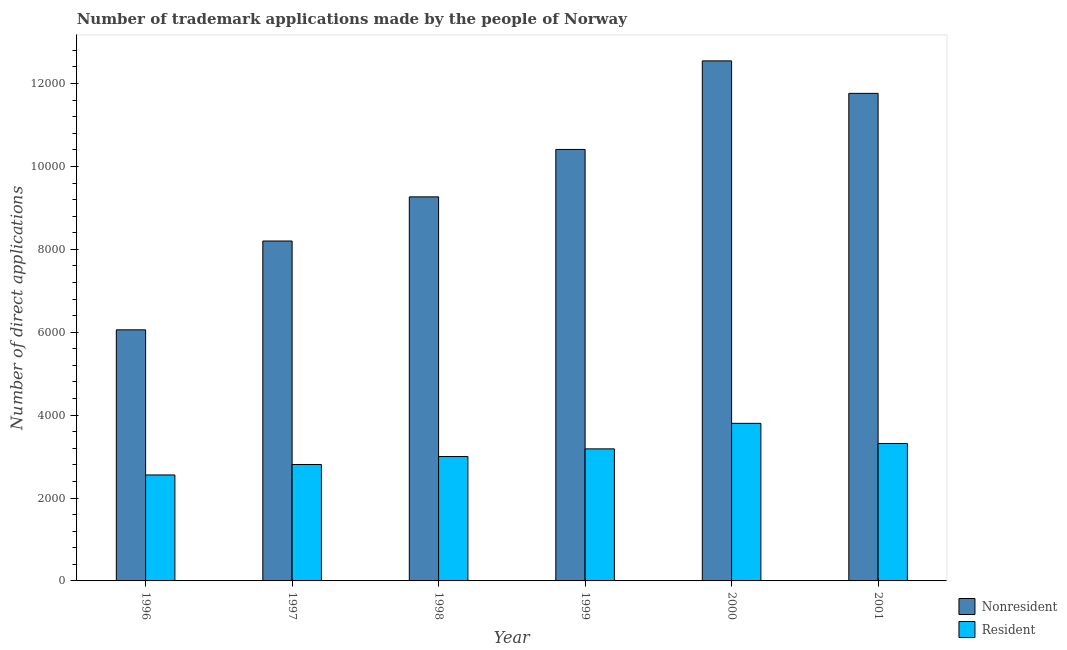How many different coloured bars are there?
Your answer should be very brief. 2. How many groups of bars are there?
Your answer should be very brief. 6. How many bars are there on the 1st tick from the left?
Provide a short and direct response. 2. What is the number of trademark applications made by residents in 1997?
Make the answer very short. 2809. Across all years, what is the maximum number of trademark applications made by non residents?
Your answer should be compact. 1.25e+04. Across all years, what is the minimum number of trademark applications made by residents?
Your response must be concise. 2557. What is the total number of trademark applications made by non residents in the graph?
Your answer should be compact. 5.82e+04. What is the difference between the number of trademark applications made by residents in 1997 and that in 1999?
Your response must be concise. -377. What is the difference between the number of trademark applications made by non residents in 1997 and the number of trademark applications made by residents in 1996?
Your response must be concise. 2143. What is the average number of trademark applications made by residents per year?
Offer a very short reply. 3111.83. In how many years, is the number of trademark applications made by residents greater than 6000?
Make the answer very short. 0. What is the ratio of the number of trademark applications made by non residents in 1997 to that in 2000?
Make the answer very short. 0.65. Is the number of trademark applications made by non residents in 1996 less than that in 1999?
Make the answer very short. Yes. Is the difference between the number of trademark applications made by residents in 1998 and 2000 greater than the difference between the number of trademark applications made by non residents in 1998 and 2000?
Offer a very short reply. No. What is the difference between the highest and the second highest number of trademark applications made by non residents?
Keep it short and to the point. 784. What is the difference between the highest and the lowest number of trademark applications made by residents?
Make the answer very short. 1245. What does the 2nd bar from the left in 1999 represents?
Offer a terse response. Resident. What does the 1st bar from the right in 1999 represents?
Offer a terse response. Resident. How many bars are there?
Your answer should be compact. 12. Are all the bars in the graph horizontal?
Keep it short and to the point. No. How many years are there in the graph?
Provide a succinct answer. 6. Does the graph contain any zero values?
Make the answer very short. No. Where does the legend appear in the graph?
Provide a short and direct response. Bottom right. What is the title of the graph?
Keep it short and to the point. Number of trademark applications made by the people of Norway. Does "Electricity" appear as one of the legend labels in the graph?
Provide a succinct answer. No. What is the label or title of the Y-axis?
Your answer should be compact. Number of direct applications. What is the Number of direct applications of Nonresident in 1996?
Ensure brevity in your answer.  6058. What is the Number of direct applications of Resident in 1996?
Keep it short and to the point. 2557. What is the Number of direct applications in Nonresident in 1997?
Ensure brevity in your answer.  8201. What is the Number of direct applications in Resident in 1997?
Give a very brief answer. 2809. What is the Number of direct applications in Nonresident in 1998?
Offer a terse response. 9266. What is the Number of direct applications in Resident in 1998?
Offer a very short reply. 3001. What is the Number of direct applications in Nonresident in 1999?
Provide a succinct answer. 1.04e+04. What is the Number of direct applications of Resident in 1999?
Provide a succinct answer. 3186. What is the Number of direct applications of Nonresident in 2000?
Give a very brief answer. 1.25e+04. What is the Number of direct applications in Resident in 2000?
Your answer should be compact. 3802. What is the Number of direct applications of Nonresident in 2001?
Your answer should be compact. 1.18e+04. What is the Number of direct applications in Resident in 2001?
Provide a short and direct response. 3316. Across all years, what is the maximum Number of direct applications in Nonresident?
Give a very brief answer. 1.25e+04. Across all years, what is the maximum Number of direct applications of Resident?
Your answer should be very brief. 3802. Across all years, what is the minimum Number of direct applications of Nonresident?
Offer a terse response. 6058. Across all years, what is the minimum Number of direct applications of Resident?
Your response must be concise. 2557. What is the total Number of direct applications of Nonresident in the graph?
Your answer should be compact. 5.82e+04. What is the total Number of direct applications in Resident in the graph?
Your response must be concise. 1.87e+04. What is the difference between the Number of direct applications of Nonresident in 1996 and that in 1997?
Give a very brief answer. -2143. What is the difference between the Number of direct applications in Resident in 1996 and that in 1997?
Make the answer very short. -252. What is the difference between the Number of direct applications in Nonresident in 1996 and that in 1998?
Keep it short and to the point. -3208. What is the difference between the Number of direct applications of Resident in 1996 and that in 1998?
Your response must be concise. -444. What is the difference between the Number of direct applications in Nonresident in 1996 and that in 1999?
Provide a succinct answer. -4352. What is the difference between the Number of direct applications in Resident in 1996 and that in 1999?
Provide a succinct answer. -629. What is the difference between the Number of direct applications in Nonresident in 1996 and that in 2000?
Make the answer very short. -6489. What is the difference between the Number of direct applications of Resident in 1996 and that in 2000?
Make the answer very short. -1245. What is the difference between the Number of direct applications in Nonresident in 1996 and that in 2001?
Offer a terse response. -5705. What is the difference between the Number of direct applications of Resident in 1996 and that in 2001?
Your answer should be compact. -759. What is the difference between the Number of direct applications of Nonresident in 1997 and that in 1998?
Make the answer very short. -1065. What is the difference between the Number of direct applications of Resident in 1997 and that in 1998?
Give a very brief answer. -192. What is the difference between the Number of direct applications of Nonresident in 1997 and that in 1999?
Make the answer very short. -2209. What is the difference between the Number of direct applications of Resident in 1997 and that in 1999?
Make the answer very short. -377. What is the difference between the Number of direct applications of Nonresident in 1997 and that in 2000?
Offer a terse response. -4346. What is the difference between the Number of direct applications of Resident in 1997 and that in 2000?
Offer a very short reply. -993. What is the difference between the Number of direct applications in Nonresident in 1997 and that in 2001?
Keep it short and to the point. -3562. What is the difference between the Number of direct applications of Resident in 1997 and that in 2001?
Your response must be concise. -507. What is the difference between the Number of direct applications of Nonresident in 1998 and that in 1999?
Ensure brevity in your answer.  -1144. What is the difference between the Number of direct applications in Resident in 1998 and that in 1999?
Your answer should be very brief. -185. What is the difference between the Number of direct applications in Nonresident in 1998 and that in 2000?
Your answer should be very brief. -3281. What is the difference between the Number of direct applications in Resident in 1998 and that in 2000?
Keep it short and to the point. -801. What is the difference between the Number of direct applications of Nonresident in 1998 and that in 2001?
Offer a very short reply. -2497. What is the difference between the Number of direct applications of Resident in 1998 and that in 2001?
Your response must be concise. -315. What is the difference between the Number of direct applications of Nonresident in 1999 and that in 2000?
Provide a short and direct response. -2137. What is the difference between the Number of direct applications of Resident in 1999 and that in 2000?
Keep it short and to the point. -616. What is the difference between the Number of direct applications of Nonresident in 1999 and that in 2001?
Offer a very short reply. -1353. What is the difference between the Number of direct applications of Resident in 1999 and that in 2001?
Your answer should be very brief. -130. What is the difference between the Number of direct applications of Nonresident in 2000 and that in 2001?
Your answer should be compact. 784. What is the difference between the Number of direct applications in Resident in 2000 and that in 2001?
Your answer should be compact. 486. What is the difference between the Number of direct applications of Nonresident in 1996 and the Number of direct applications of Resident in 1997?
Your response must be concise. 3249. What is the difference between the Number of direct applications of Nonresident in 1996 and the Number of direct applications of Resident in 1998?
Keep it short and to the point. 3057. What is the difference between the Number of direct applications of Nonresident in 1996 and the Number of direct applications of Resident in 1999?
Offer a terse response. 2872. What is the difference between the Number of direct applications of Nonresident in 1996 and the Number of direct applications of Resident in 2000?
Your answer should be compact. 2256. What is the difference between the Number of direct applications in Nonresident in 1996 and the Number of direct applications in Resident in 2001?
Provide a succinct answer. 2742. What is the difference between the Number of direct applications in Nonresident in 1997 and the Number of direct applications in Resident in 1998?
Give a very brief answer. 5200. What is the difference between the Number of direct applications of Nonresident in 1997 and the Number of direct applications of Resident in 1999?
Ensure brevity in your answer.  5015. What is the difference between the Number of direct applications in Nonresident in 1997 and the Number of direct applications in Resident in 2000?
Ensure brevity in your answer.  4399. What is the difference between the Number of direct applications in Nonresident in 1997 and the Number of direct applications in Resident in 2001?
Ensure brevity in your answer.  4885. What is the difference between the Number of direct applications of Nonresident in 1998 and the Number of direct applications of Resident in 1999?
Ensure brevity in your answer.  6080. What is the difference between the Number of direct applications of Nonresident in 1998 and the Number of direct applications of Resident in 2000?
Make the answer very short. 5464. What is the difference between the Number of direct applications in Nonresident in 1998 and the Number of direct applications in Resident in 2001?
Offer a terse response. 5950. What is the difference between the Number of direct applications in Nonresident in 1999 and the Number of direct applications in Resident in 2000?
Offer a terse response. 6608. What is the difference between the Number of direct applications in Nonresident in 1999 and the Number of direct applications in Resident in 2001?
Your answer should be compact. 7094. What is the difference between the Number of direct applications of Nonresident in 2000 and the Number of direct applications of Resident in 2001?
Ensure brevity in your answer.  9231. What is the average Number of direct applications in Nonresident per year?
Ensure brevity in your answer.  9707.5. What is the average Number of direct applications in Resident per year?
Offer a very short reply. 3111.83. In the year 1996, what is the difference between the Number of direct applications of Nonresident and Number of direct applications of Resident?
Offer a terse response. 3501. In the year 1997, what is the difference between the Number of direct applications of Nonresident and Number of direct applications of Resident?
Provide a short and direct response. 5392. In the year 1998, what is the difference between the Number of direct applications of Nonresident and Number of direct applications of Resident?
Offer a very short reply. 6265. In the year 1999, what is the difference between the Number of direct applications of Nonresident and Number of direct applications of Resident?
Make the answer very short. 7224. In the year 2000, what is the difference between the Number of direct applications of Nonresident and Number of direct applications of Resident?
Provide a short and direct response. 8745. In the year 2001, what is the difference between the Number of direct applications in Nonresident and Number of direct applications in Resident?
Give a very brief answer. 8447. What is the ratio of the Number of direct applications of Nonresident in 1996 to that in 1997?
Offer a very short reply. 0.74. What is the ratio of the Number of direct applications in Resident in 1996 to that in 1997?
Make the answer very short. 0.91. What is the ratio of the Number of direct applications of Nonresident in 1996 to that in 1998?
Give a very brief answer. 0.65. What is the ratio of the Number of direct applications in Resident in 1996 to that in 1998?
Give a very brief answer. 0.85. What is the ratio of the Number of direct applications in Nonresident in 1996 to that in 1999?
Give a very brief answer. 0.58. What is the ratio of the Number of direct applications in Resident in 1996 to that in 1999?
Make the answer very short. 0.8. What is the ratio of the Number of direct applications in Nonresident in 1996 to that in 2000?
Give a very brief answer. 0.48. What is the ratio of the Number of direct applications in Resident in 1996 to that in 2000?
Provide a succinct answer. 0.67. What is the ratio of the Number of direct applications of Nonresident in 1996 to that in 2001?
Keep it short and to the point. 0.52. What is the ratio of the Number of direct applications of Resident in 1996 to that in 2001?
Keep it short and to the point. 0.77. What is the ratio of the Number of direct applications in Nonresident in 1997 to that in 1998?
Offer a terse response. 0.89. What is the ratio of the Number of direct applications in Resident in 1997 to that in 1998?
Your response must be concise. 0.94. What is the ratio of the Number of direct applications of Nonresident in 1997 to that in 1999?
Make the answer very short. 0.79. What is the ratio of the Number of direct applications in Resident in 1997 to that in 1999?
Provide a short and direct response. 0.88. What is the ratio of the Number of direct applications of Nonresident in 1997 to that in 2000?
Keep it short and to the point. 0.65. What is the ratio of the Number of direct applications of Resident in 1997 to that in 2000?
Ensure brevity in your answer.  0.74. What is the ratio of the Number of direct applications in Nonresident in 1997 to that in 2001?
Make the answer very short. 0.7. What is the ratio of the Number of direct applications of Resident in 1997 to that in 2001?
Make the answer very short. 0.85. What is the ratio of the Number of direct applications of Nonresident in 1998 to that in 1999?
Provide a succinct answer. 0.89. What is the ratio of the Number of direct applications of Resident in 1998 to that in 1999?
Provide a succinct answer. 0.94. What is the ratio of the Number of direct applications in Nonresident in 1998 to that in 2000?
Keep it short and to the point. 0.74. What is the ratio of the Number of direct applications of Resident in 1998 to that in 2000?
Offer a very short reply. 0.79. What is the ratio of the Number of direct applications in Nonresident in 1998 to that in 2001?
Your answer should be very brief. 0.79. What is the ratio of the Number of direct applications of Resident in 1998 to that in 2001?
Give a very brief answer. 0.91. What is the ratio of the Number of direct applications of Nonresident in 1999 to that in 2000?
Make the answer very short. 0.83. What is the ratio of the Number of direct applications of Resident in 1999 to that in 2000?
Make the answer very short. 0.84. What is the ratio of the Number of direct applications of Nonresident in 1999 to that in 2001?
Give a very brief answer. 0.89. What is the ratio of the Number of direct applications in Resident in 1999 to that in 2001?
Give a very brief answer. 0.96. What is the ratio of the Number of direct applications in Nonresident in 2000 to that in 2001?
Your answer should be compact. 1.07. What is the ratio of the Number of direct applications in Resident in 2000 to that in 2001?
Offer a terse response. 1.15. What is the difference between the highest and the second highest Number of direct applications of Nonresident?
Offer a terse response. 784. What is the difference between the highest and the second highest Number of direct applications in Resident?
Give a very brief answer. 486. What is the difference between the highest and the lowest Number of direct applications of Nonresident?
Make the answer very short. 6489. What is the difference between the highest and the lowest Number of direct applications of Resident?
Your answer should be compact. 1245. 